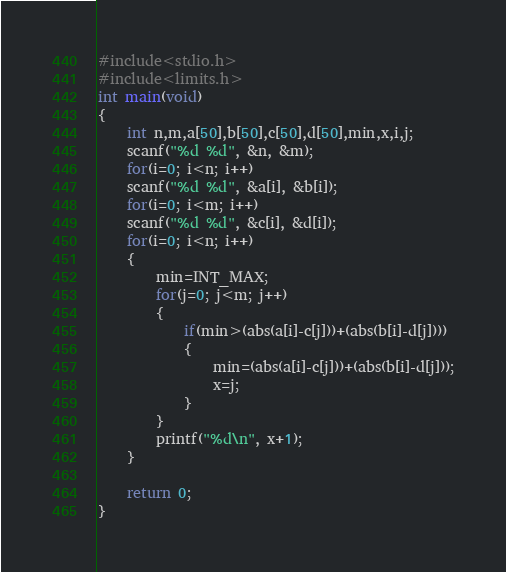Convert code to text. <code><loc_0><loc_0><loc_500><loc_500><_C_>#include<stdio.h>
#include<limits.h>
int main(void)
{
	int n,m,a[50],b[50],c[50],d[50],min,x,i,j;
	scanf("%d %d", &n, &m);
	for(i=0; i<n; i++)
	scanf("%d %d", &a[i], &b[i]);
	for(i=0; i<m; i++)
	scanf("%d %d", &c[i], &d[i]);
	for(i=0; i<n; i++)
	{
		min=INT_MAX;
		for(j=0; j<m; j++)
		{
			if(min>(abs(a[i]-c[j]))+(abs(b[i]-d[j])))
			{
				min=(abs(a[i]-c[j]))+(abs(b[i]-d[j]));
				x=j;
			}
		}
		printf("%d\n", x+1);
	}
	
	return 0;
}</code> 